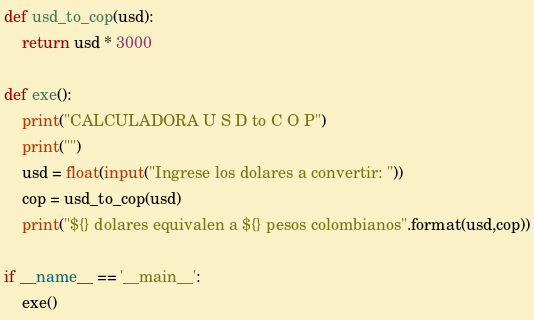Convert code to text. <code><loc_0><loc_0><loc_500><loc_500><_Python_>
def usd_to_cop(usd):
	return usd * 3000

def exe():
	print("CALCULADORA U S D to C O P")
	print("")
	usd = float(input("Ingrese los dolares a convertir: "))
	cop = usd_to_cop(usd)
	print("${} dolares equivalen a ${} pesos colombianos".format(usd,cop))

if __name__ == '__main__':
	exe()</code> 